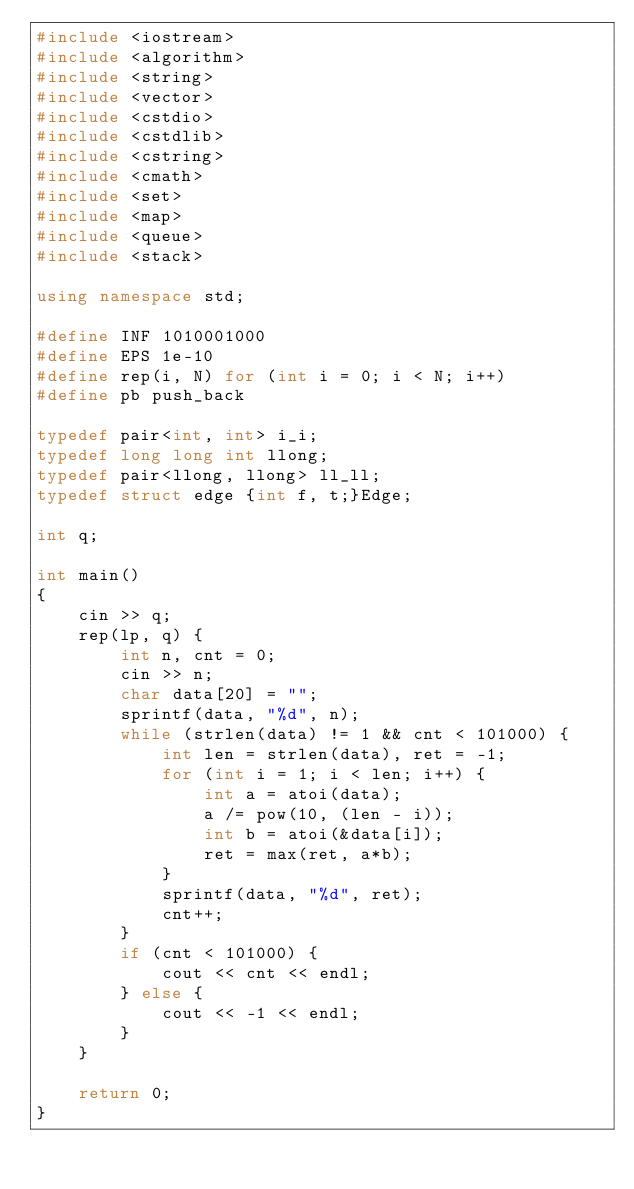<code> <loc_0><loc_0><loc_500><loc_500><_C++_>#include <iostream>
#include <algorithm>
#include <string>
#include <vector>
#include <cstdio>
#include <cstdlib>
#include <cstring>
#include <cmath>
#include <set>
#include <map>
#include <queue>
#include <stack>

using namespace std;

#define INF 1010001000
#define EPS 1e-10
#define rep(i, N) for (int i = 0; i < N; i++)
#define pb push_back

typedef pair<int, int> i_i;
typedef long long int llong;
typedef pair<llong, llong> ll_ll;
typedef struct edge {int f, t;}Edge;

int q;

int main()
{
    cin >> q;
    rep(lp, q) {
        int n, cnt = 0;
        cin >> n;
        char data[20] = "";
        sprintf(data, "%d", n);
        while (strlen(data) != 1 && cnt < 101000) {
            int len = strlen(data), ret = -1;
            for (int i = 1; i < len; i++) {
                int a = atoi(data);
                a /= pow(10, (len - i));
                int b = atoi(&data[i]);
                ret = max(ret, a*b);
            }
            sprintf(data, "%d", ret);
            cnt++;
        }
        if (cnt < 101000) {
            cout << cnt << endl;
        } else {
            cout << -1 << endl;
        }
    }

    return 0;
}</code> 